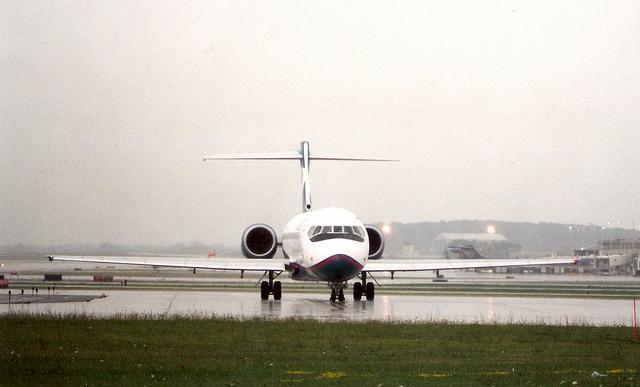How many propellers on the plane?
Give a very brief answer. 0. How many men are in the picture?
Give a very brief answer. 0. 